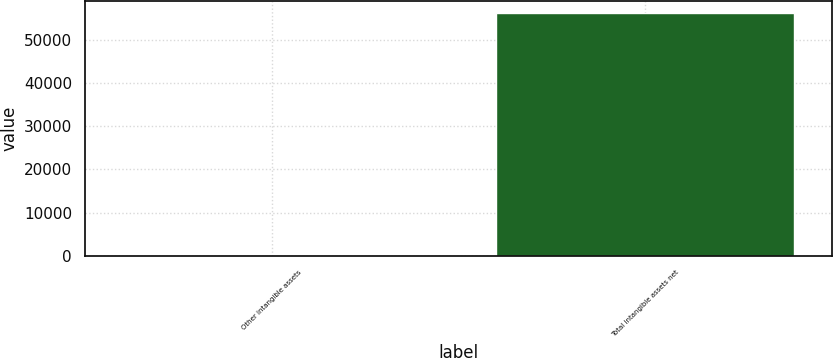<chart> <loc_0><loc_0><loc_500><loc_500><bar_chart><fcel>Other intangible assets<fcel>Total intangible assets net<nl><fcel>37<fcel>56224<nl></chart> 